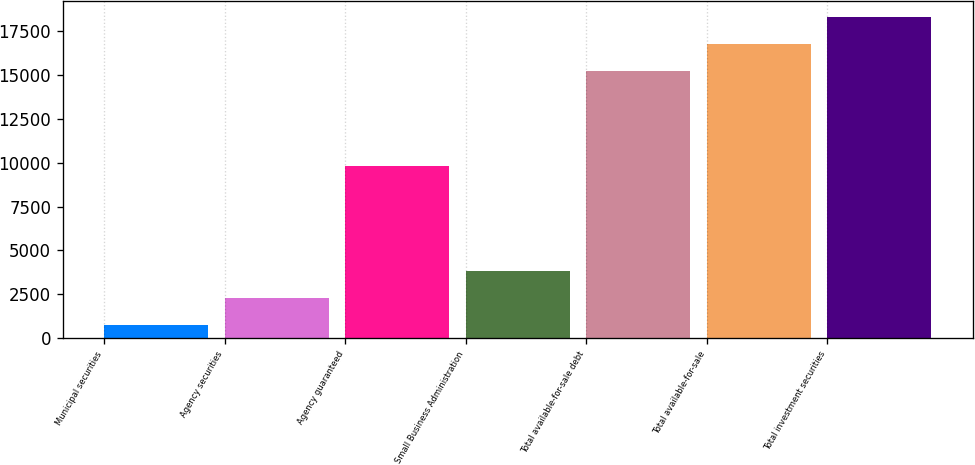Convert chart. <chart><loc_0><loc_0><loc_500><loc_500><bar_chart><fcel>Municipal securities<fcel>Agency securities<fcel>Agency guaranteed<fcel>Small Business Administration<fcel>Total available-for-sale debt<fcel>Total available-for-sale<fcel>Total investment securities<nl><fcel>770<fcel>2301.3<fcel>9798<fcel>3832.6<fcel>15241<fcel>16772.3<fcel>18303.6<nl></chart> 